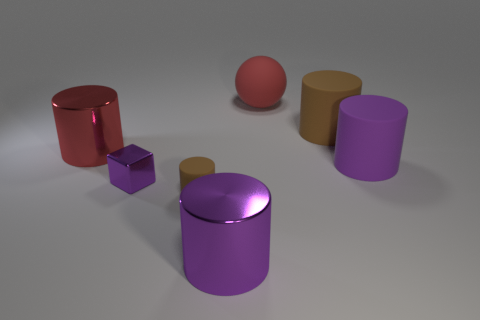There is a small brown thing that is the same material as the big red ball; what is its shape?
Keep it short and to the point. Cylinder. There is a brown rubber cylinder that is in front of the red metal cylinder; is it the same size as the brown rubber cylinder that is on the right side of the sphere?
Provide a short and direct response. No. Are there more large purple metal objects that are on the right side of the big red sphere than big purple cylinders that are in front of the tiny purple metallic cube?
Offer a very short reply. No. What number of other objects are there of the same color as the small block?
Offer a terse response. 2. Do the sphere and the shiny object that is behind the purple matte cylinder have the same color?
Ensure brevity in your answer.  Yes. There is a brown thing that is in front of the large purple rubber thing; how many small brown matte objects are in front of it?
Make the answer very short. 0. Is there anything else that is made of the same material as the small block?
Your answer should be very brief. Yes. The big red thing left of the big metal thing in front of the big metal cylinder that is behind the small brown rubber object is made of what material?
Give a very brief answer. Metal. The purple thing that is both on the right side of the tiny metallic thing and behind the small rubber thing is made of what material?
Keep it short and to the point. Rubber. How many other small objects are the same shape as the tiny metallic thing?
Offer a terse response. 0. 